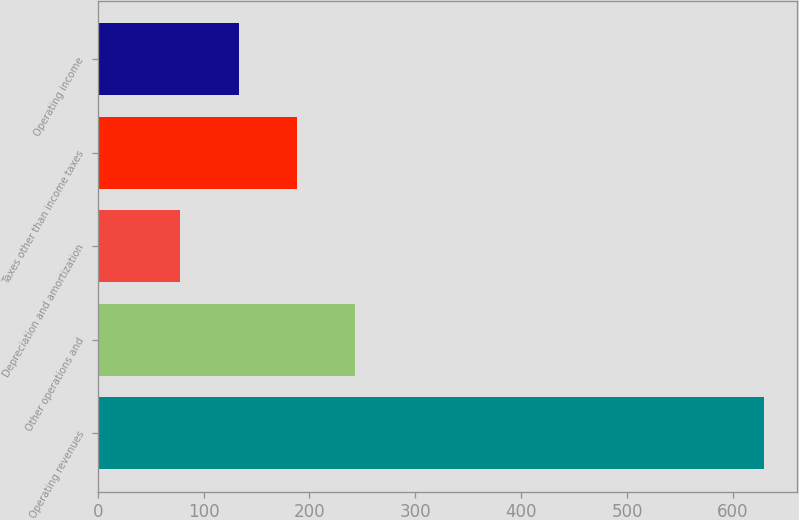Convert chart. <chart><loc_0><loc_0><loc_500><loc_500><bar_chart><fcel>Operating revenues<fcel>Other operations and<fcel>Depreciation and amortization<fcel>Taxes other than income taxes<fcel>Operating income<nl><fcel>629<fcel>243.3<fcel>78<fcel>188.2<fcel>133.1<nl></chart> 